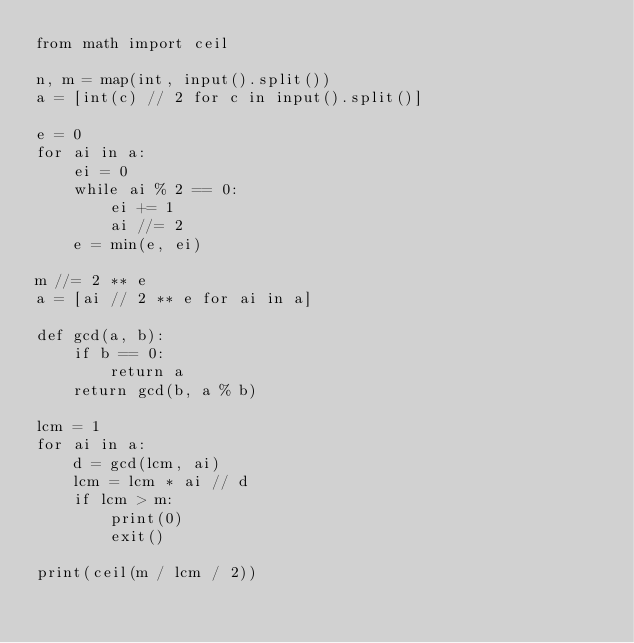Convert code to text. <code><loc_0><loc_0><loc_500><loc_500><_Python_>from math import ceil

n, m = map(int, input().split())
a = [int(c) // 2 for c in input().split()]

e = 0
for ai in a:
    ei = 0
    while ai % 2 == 0:
        ei += 1
        ai //= 2
    e = min(e, ei)

m //= 2 ** e
a = [ai // 2 ** e for ai in a]

def gcd(a, b):
    if b == 0:
        return a
    return gcd(b, a % b)

lcm = 1
for ai in a:
    d = gcd(lcm, ai)
    lcm = lcm * ai // d
    if lcm > m:
        print(0)
        exit()

print(ceil(m / lcm / 2))
</code> 